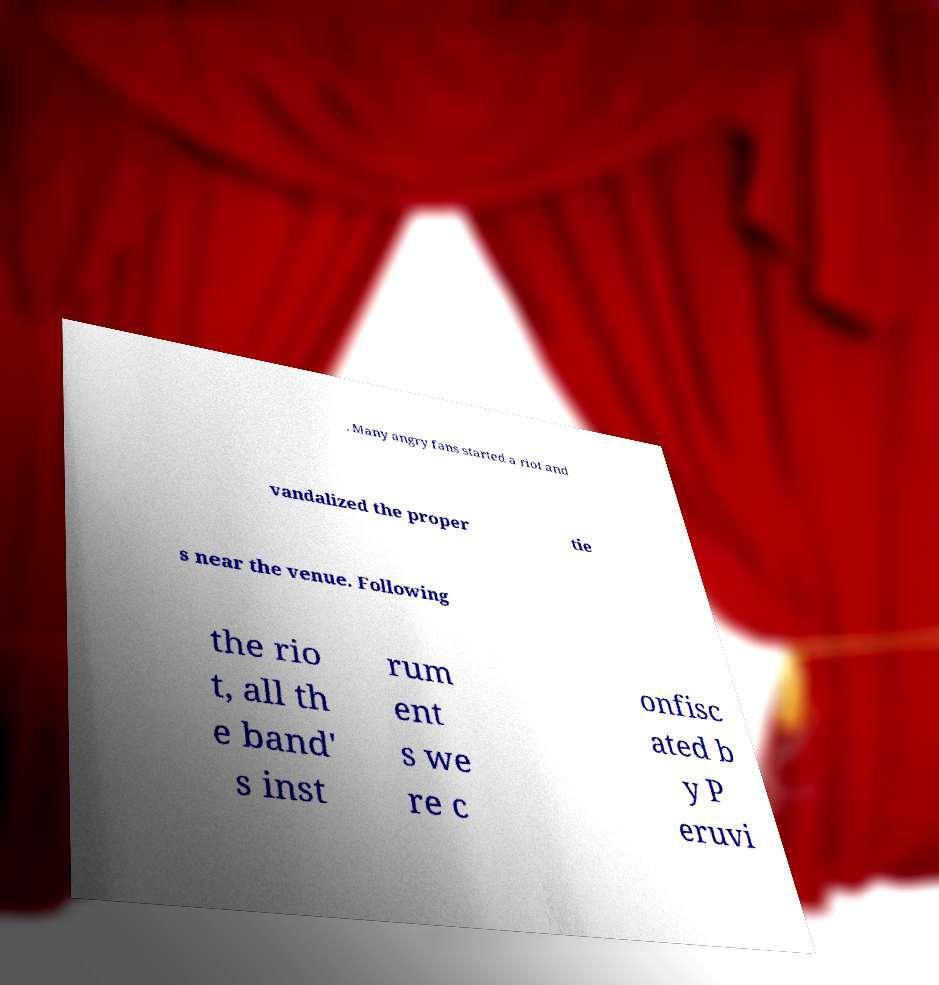Can you read and provide the text displayed in the image?This photo seems to have some interesting text. Can you extract and type it out for me? . Many angry fans started a riot and vandalized the proper tie s near the venue. Following the rio t, all th e band' s inst rum ent s we re c onfisc ated b y P eruvi 